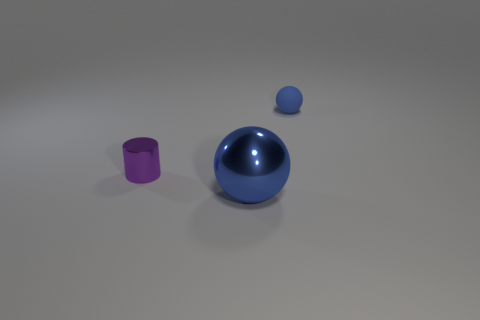Add 2 brown blocks. How many objects exist? 5 Add 3 small cylinders. How many small cylinders exist? 4 Subtract 0 brown blocks. How many objects are left? 3 Subtract all spheres. How many objects are left? 1 Subtract all cyan spheres. Subtract all cyan blocks. How many spheres are left? 2 Subtract all rubber spheres. Subtract all small purple cylinders. How many objects are left? 1 Add 2 rubber objects. How many rubber objects are left? 3 